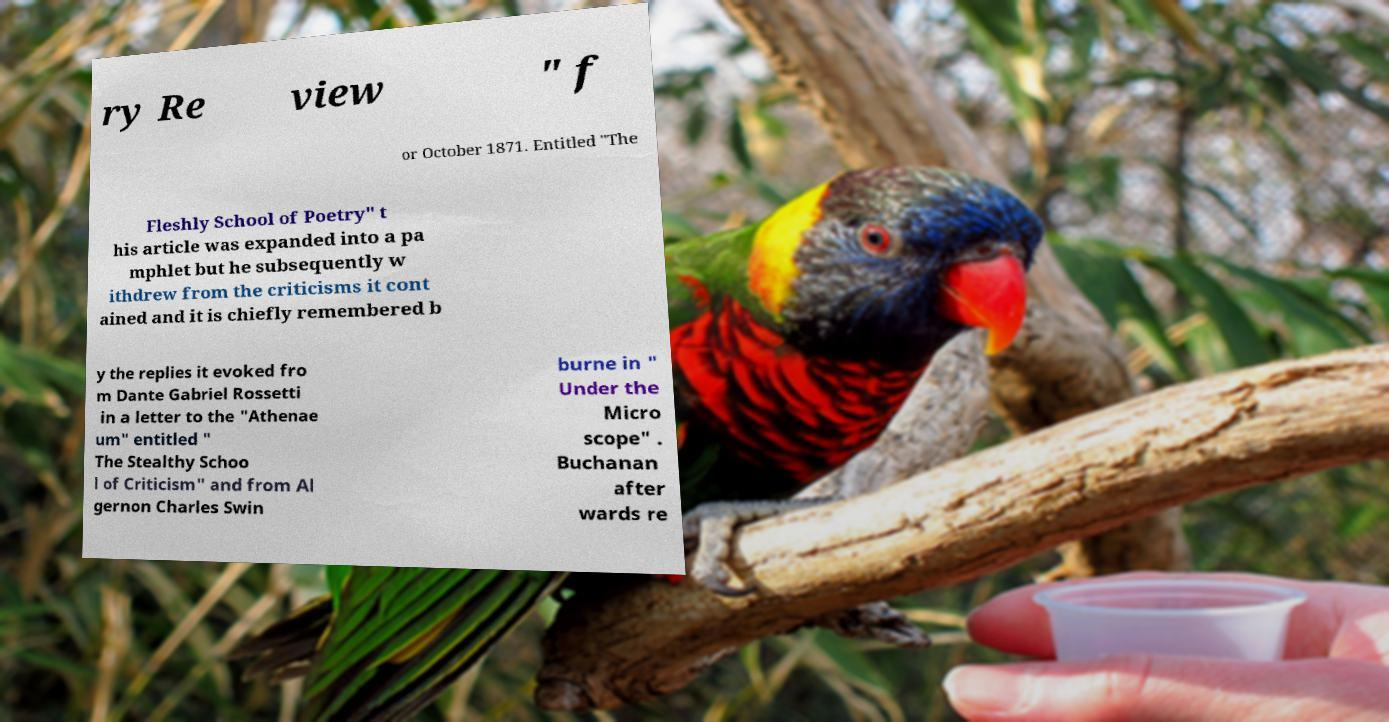Please read and relay the text visible in this image. What does it say? ry Re view " f or October 1871. Entitled "The Fleshly School of Poetry" t his article was expanded into a pa mphlet but he subsequently w ithdrew from the criticisms it cont ained and it is chiefly remembered b y the replies it evoked fro m Dante Gabriel Rossetti in a letter to the "Athenae um" entitled " The Stealthy Schoo l of Criticism" and from Al gernon Charles Swin burne in " Under the Micro scope" . Buchanan after wards re 